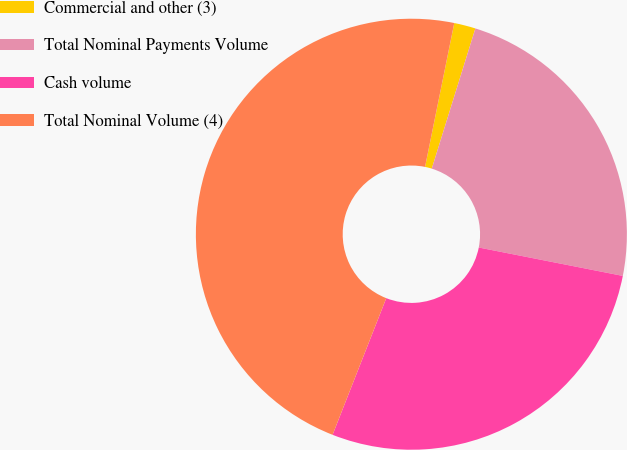Convert chart. <chart><loc_0><loc_0><loc_500><loc_500><pie_chart><fcel>Commercial and other (3)<fcel>Total Nominal Payments Volume<fcel>Cash volume<fcel>Total Nominal Volume (4)<nl><fcel>1.61%<fcel>23.3%<fcel>27.86%<fcel>47.23%<nl></chart> 